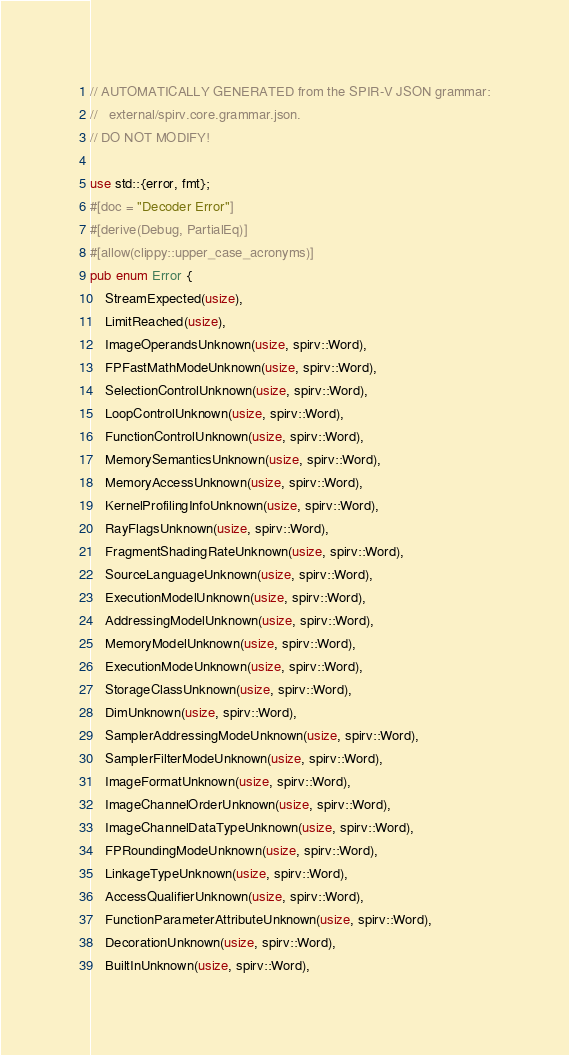<code> <loc_0><loc_0><loc_500><loc_500><_Rust_>// AUTOMATICALLY GENERATED from the SPIR-V JSON grammar:
//   external/spirv.core.grammar.json.
// DO NOT MODIFY!

use std::{error, fmt};
#[doc = "Decoder Error"]
#[derive(Debug, PartialEq)]
#[allow(clippy::upper_case_acronyms)]
pub enum Error {
    StreamExpected(usize),
    LimitReached(usize),
    ImageOperandsUnknown(usize, spirv::Word),
    FPFastMathModeUnknown(usize, spirv::Word),
    SelectionControlUnknown(usize, spirv::Word),
    LoopControlUnknown(usize, spirv::Word),
    FunctionControlUnknown(usize, spirv::Word),
    MemorySemanticsUnknown(usize, spirv::Word),
    MemoryAccessUnknown(usize, spirv::Word),
    KernelProfilingInfoUnknown(usize, spirv::Word),
    RayFlagsUnknown(usize, spirv::Word),
    FragmentShadingRateUnknown(usize, spirv::Word),
    SourceLanguageUnknown(usize, spirv::Word),
    ExecutionModelUnknown(usize, spirv::Word),
    AddressingModelUnknown(usize, spirv::Word),
    MemoryModelUnknown(usize, spirv::Word),
    ExecutionModeUnknown(usize, spirv::Word),
    StorageClassUnknown(usize, spirv::Word),
    DimUnknown(usize, spirv::Word),
    SamplerAddressingModeUnknown(usize, spirv::Word),
    SamplerFilterModeUnknown(usize, spirv::Word),
    ImageFormatUnknown(usize, spirv::Word),
    ImageChannelOrderUnknown(usize, spirv::Word),
    ImageChannelDataTypeUnknown(usize, spirv::Word),
    FPRoundingModeUnknown(usize, spirv::Word),
    LinkageTypeUnknown(usize, spirv::Word),
    AccessQualifierUnknown(usize, spirv::Word),
    FunctionParameterAttributeUnknown(usize, spirv::Word),
    DecorationUnknown(usize, spirv::Word),
    BuiltInUnknown(usize, spirv::Word),</code> 